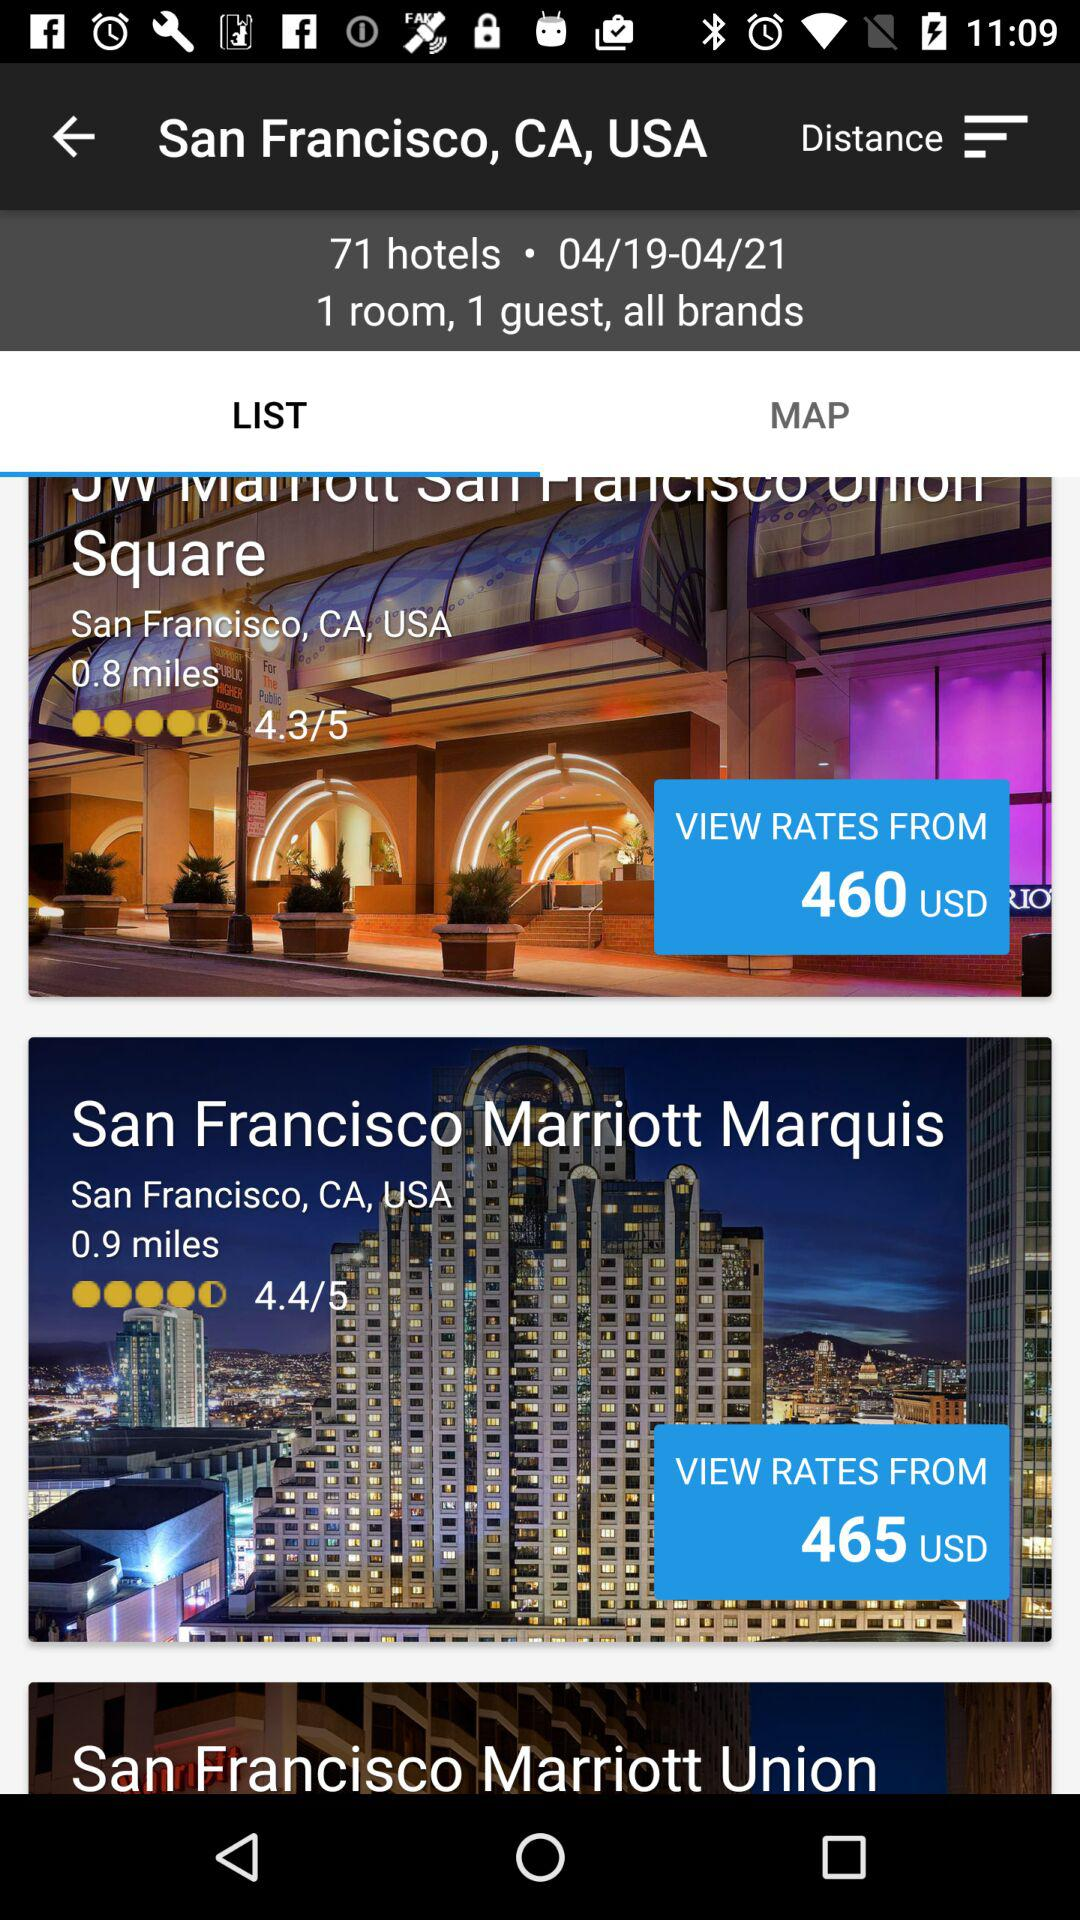How many hotels are there?
Answer the question using a single word or phrase. 71 